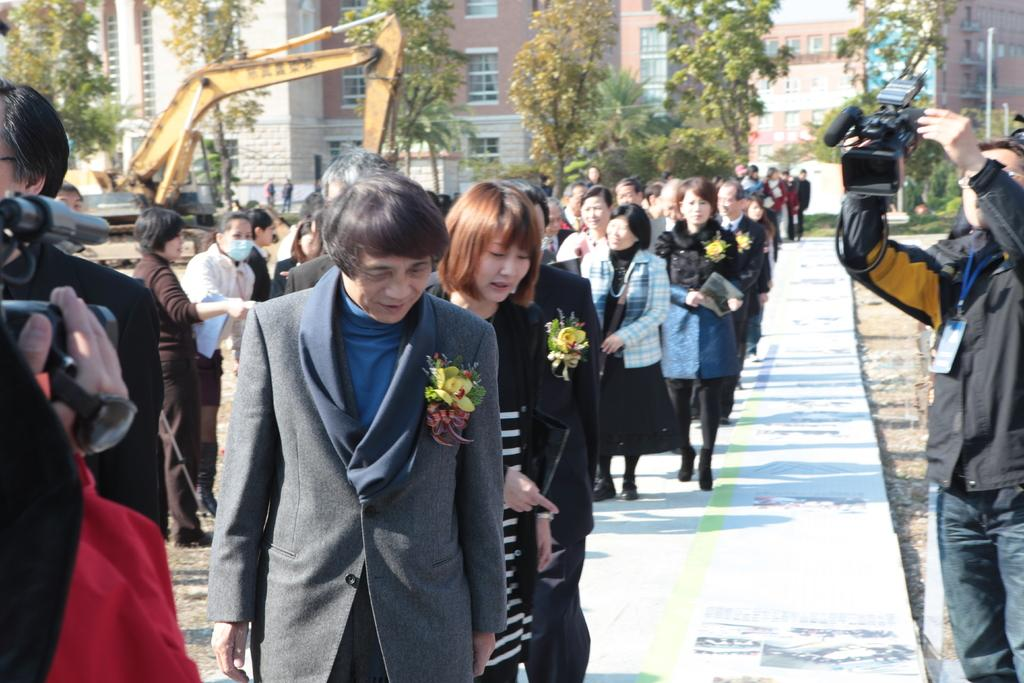What are the people in the image doing? The people in the image are walking. How are the people dressed in the image? The people are wearing different dress. Can you identify any specific object one person is holding? One person is holding a camera. What can be seen in the background of the image? There is a crane, buildings, windows, and trees visible in the background of the image. What color is the bear's leg in the image? There is no bear present in the image, so it is not possible to determine the color of its leg. 